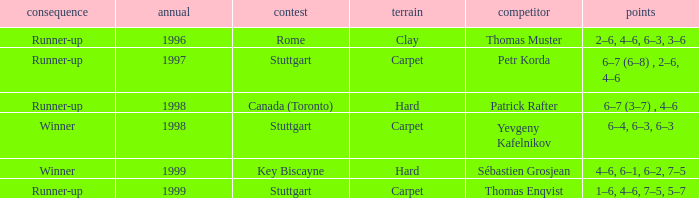In 1996, what did the surface consist of? Clay. 